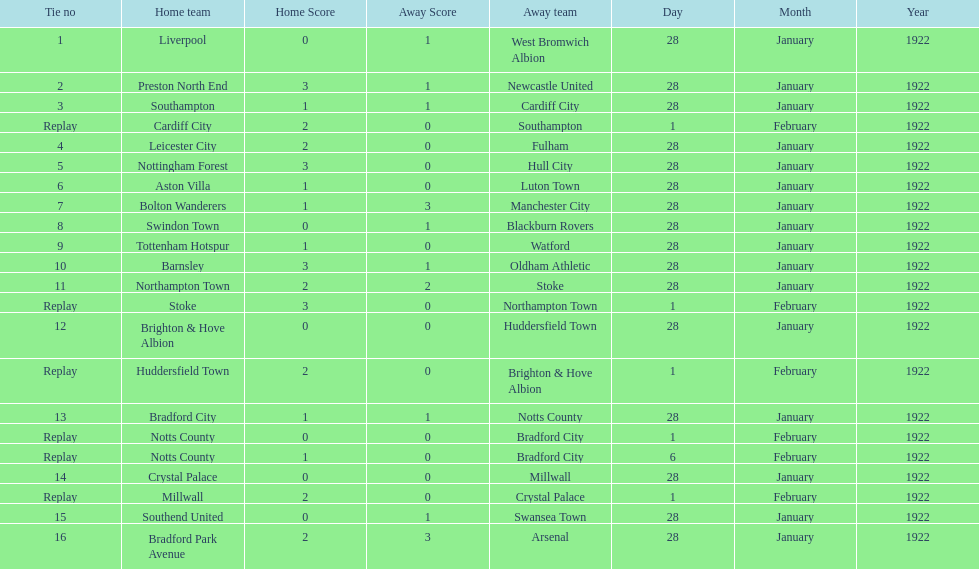What is the number of points scored on 6 february 1922? 1. 